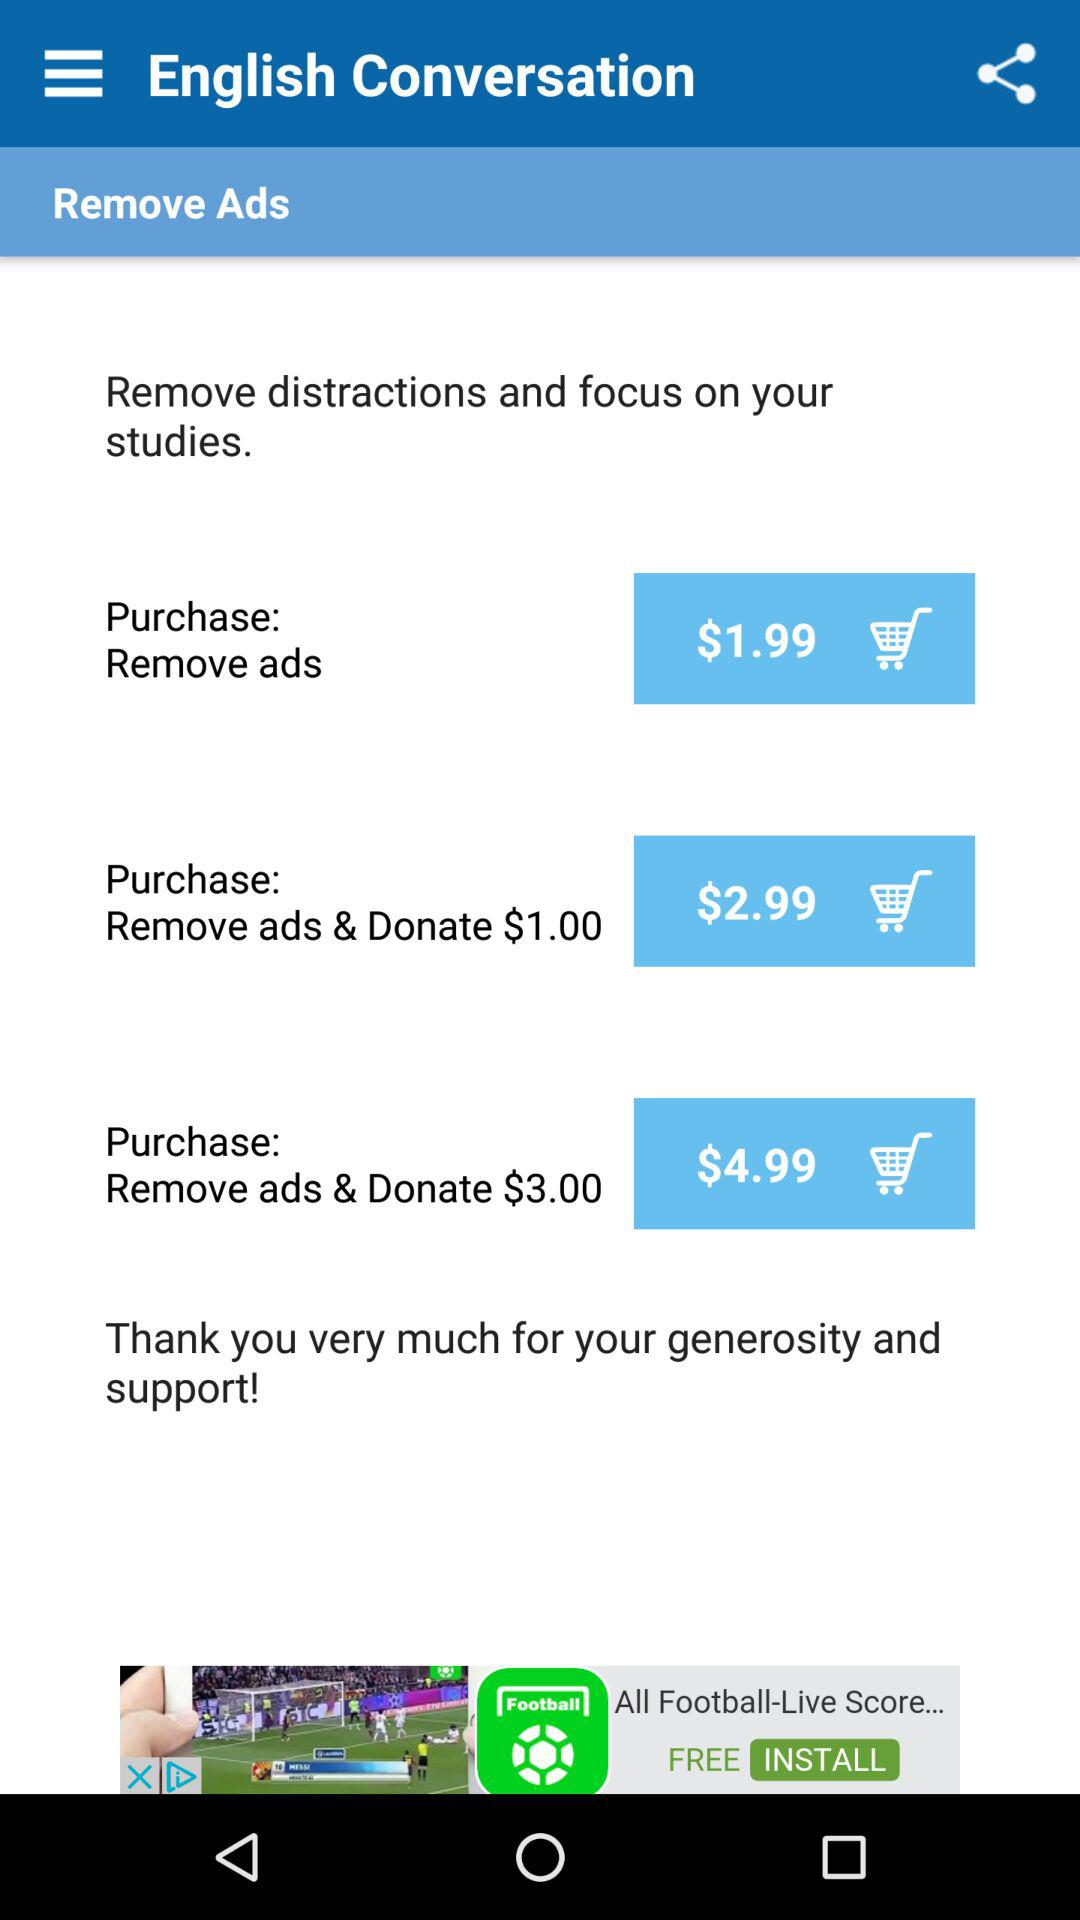How many purchase options are available?
Answer the question using a single word or phrase. 3 